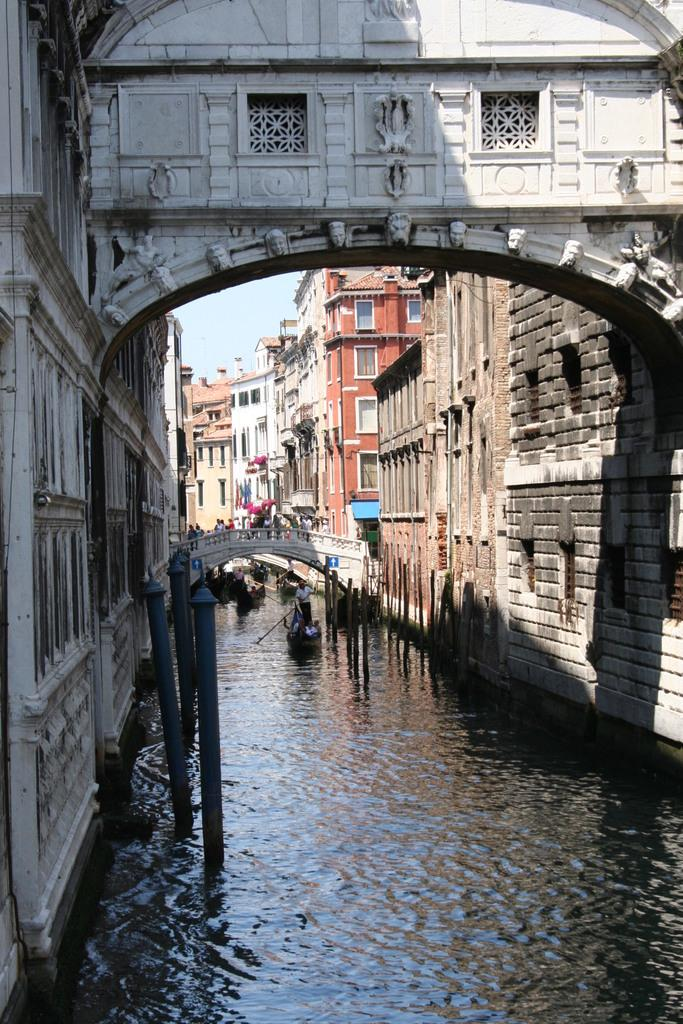What body of water is present in the image? There is a lake in the image. What activity is taking place on the lake? Boats are moving in the lake. What can be seen around the lake? There are buildings visible around the lake. Where is the zebra crossing the river in the image? There is no river or zebra present in the image; it features a lake with boats and buildings around it. 